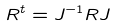Convert formula to latex. <formula><loc_0><loc_0><loc_500><loc_500>R ^ { t } = J ^ { - 1 } R J</formula> 